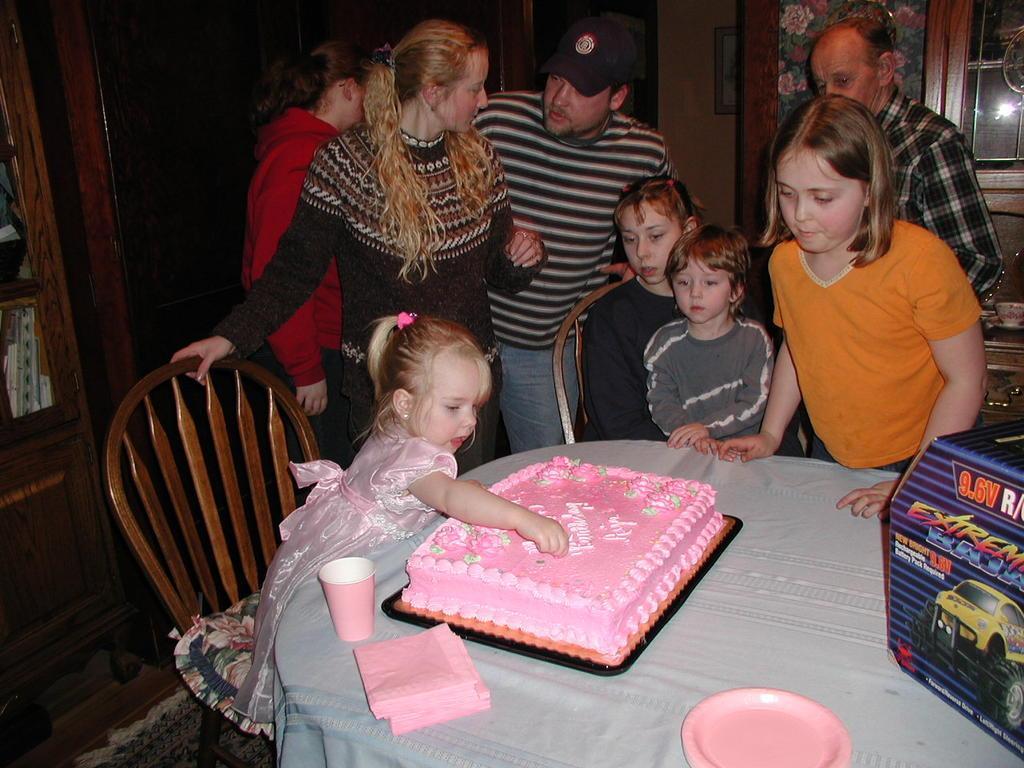Could you give a brief overview of what you see in this image? There are so many people standing and few girls sitting and behind them there is a cake on table. 